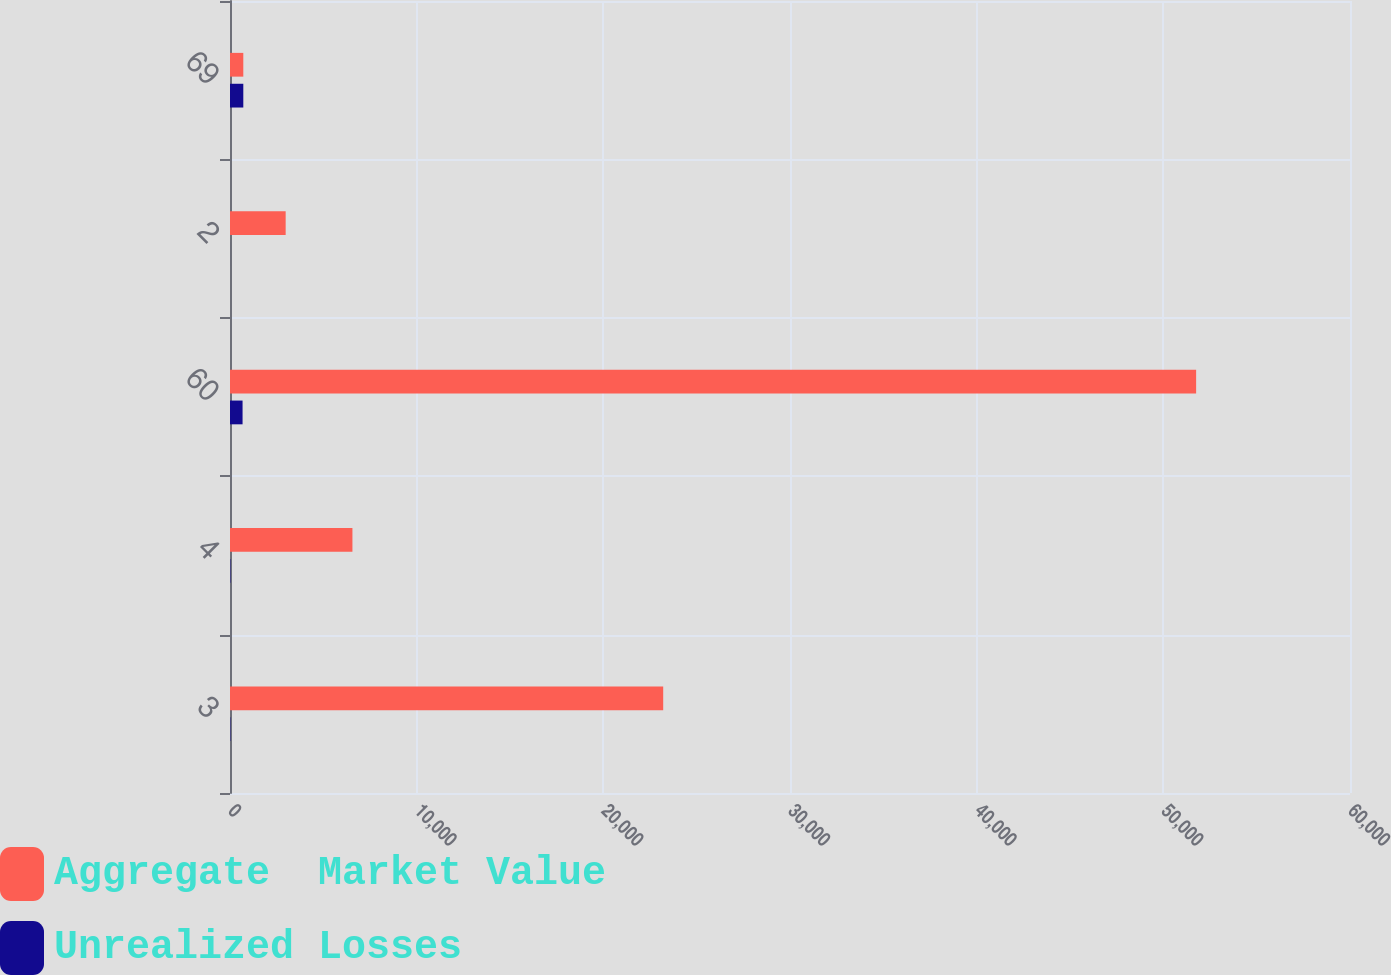<chart> <loc_0><loc_0><loc_500><loc_500><stacked_bar_chart><ecel><fcel>3<fcel>4<fcel>60<fcel>2<fcel>69<nl><fcel>Aggregate  Market Value<fcel>23207<fcel>6559<fcel>51757<fcel>2982<fcel>713<nl><fcel>Unrealized Losses<fcel>19<fcel>20<fcel>673<fcel>1<fcel>713<nl></chart> 